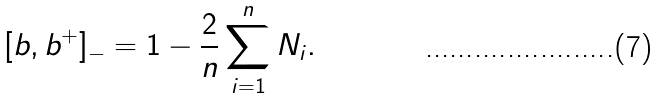Convert formula to latex. <formula><loc_0><loc_0><loc_500><loc_500>[ b , b ^ { + } ] _ { - } = 1 - \frac { 2 } { n } \sum _ { i = 1 } ^ { n } N _ { i } .</formula> 